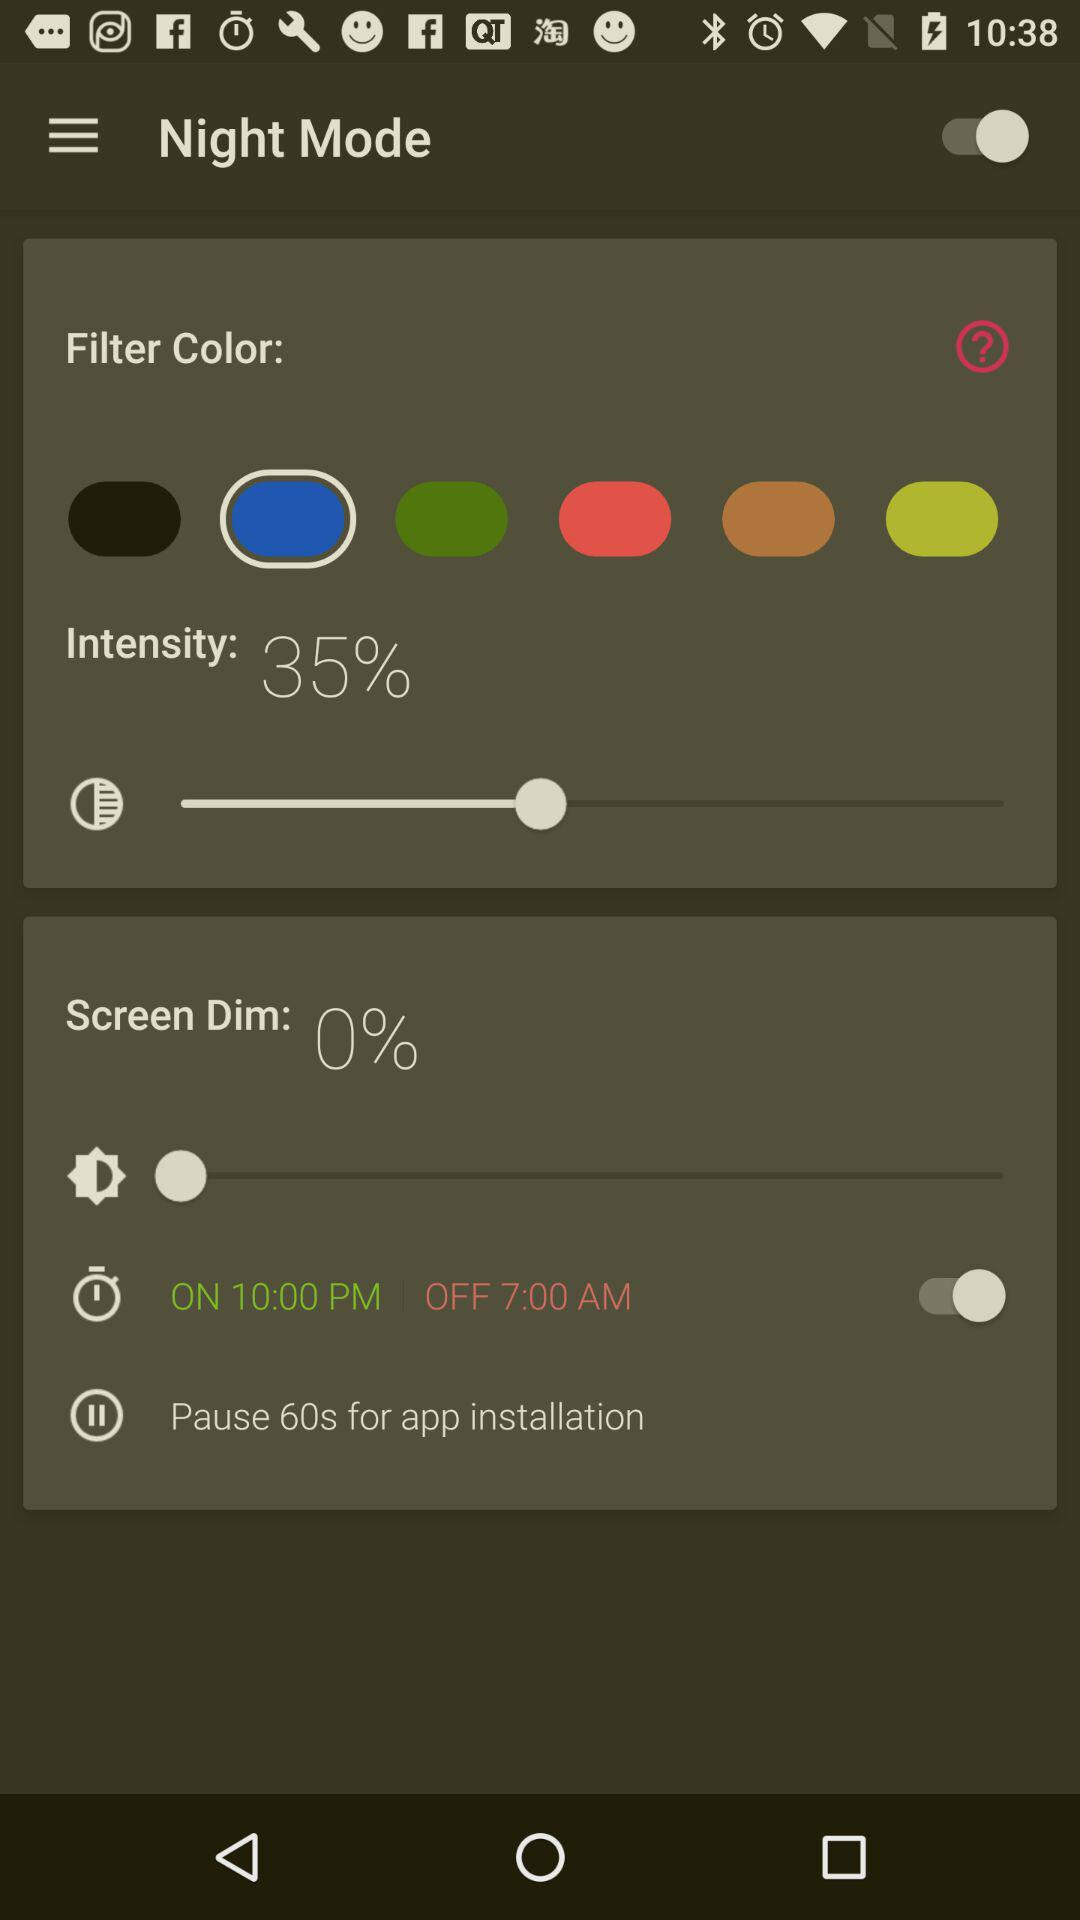What's the "ON" time? The "ON" time is 10:00 PM. 